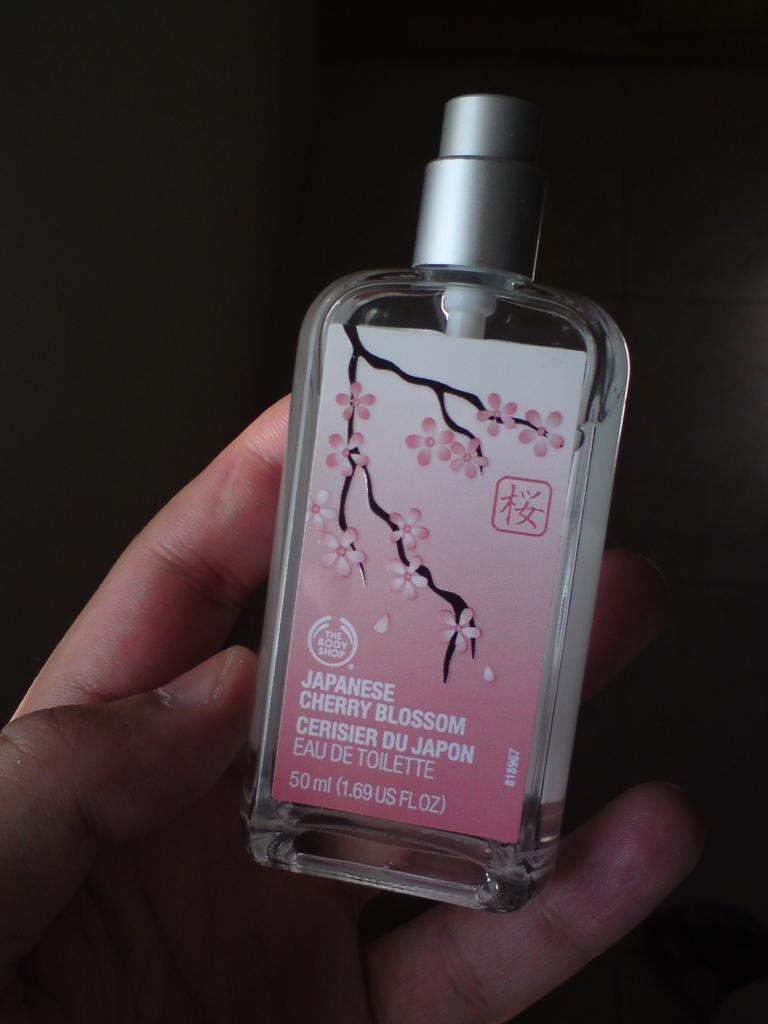<image>
Summarize the visual content of the image. Person holding a bottle of japanese Cherry Blossom. 